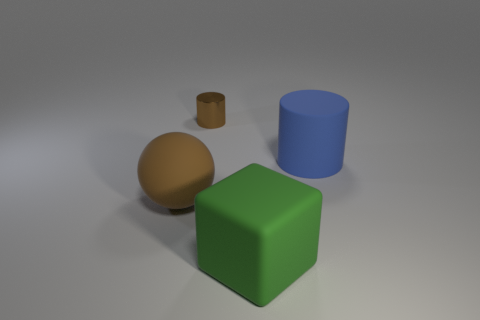Are there any other things that are made of the same material as the small cylinder?
Give a very brief answer. No. Is there a sphere of the same size as the cube?
Provide a short and direct response. Yes. There is a cylinder that is on the left side of the big rubber block; what is its material?
Offer a very short reply. Metal. Is the material of the cylinder left of the blue rubber cylinder the same as the blue object?
Your answer should be very brief. No. Are there any gray shiny spheres?
Your answer should be very brief. No. There is a large cube that is the same material as the blue cylinder; what color is it?
Your answer should be compact. Green. There is a cylinder that is behind the matte object that is right of the large rubber thing that is in front of the brown ball; what is its color?
Offer a terse response. Brown. Does the brown metallic cylinder have the same size as the cylinder right of the shiny cylinder?
Your response must be concise. No. How many things are either big things that are behind the big green rubber object or cylinders in front of the brown metallic cylinder?
Keep it short and to the point. 2. There is a blue thing that is the same size as the brown ball; what is its shape?
Your answer should be compact. Cylinder. 